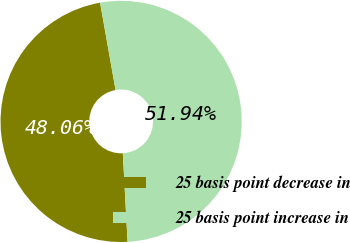<chart> <loc_0><loc_0><loc_500><loc_500><pie_chart><fcel>25 basis point decrease in<fcel>25 basis point increase in<nl><fcel>48.06%<fcel>51.94%<nl></chart> 